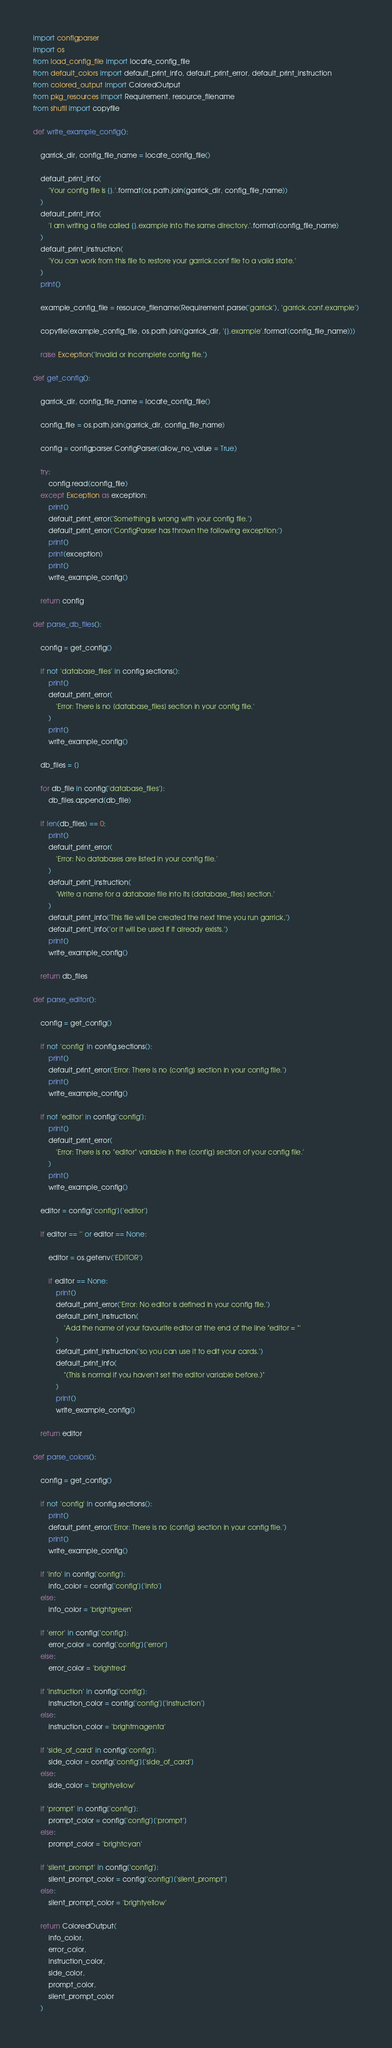<code> <loc_0><loc_0><loc_500><loc_500><_Python_>import configparser
import os
from load_config_file import locate_config_file
from default_colors import default_print_info, default_print_error, default_print_instruction
from colored_output import ColoredOutput
from pkg_resources import Requirement, resource_filename
from shutil import copyfile

def write_example_config():
    
    garrick_dir, config_file_name = locate_config_file()

    default_print_info(
        'Your config file is {}.'.format(os.path.join(garrick_dir, config_file_name))
    )
    default_print_info(
        'I am writing a file called {}.example into the same directory.'.format(config_file_name)
    )
    default_print_instruction(
        'You can work from this file to restore your garrick.conf file to a valid state.'
    )
    print()

    example_config_file = resource_filename(Requirement.parse('garrick'), 'garrick.conf.example')

    copyfile(example_config_file, os.path.join(garrick_dir, '{}.example'.format(config_file_name)))

    raise Exception('Invalid or incomplete config file.')

def get_config():
    
    garrick_dir, config_file_name = locate_config_file()

    config_file = os.path.join(garrick_dir, config_file_name)

    config = configparser.ConfigParser(allow_no_value = True)

    try:
        config.read(config_file)
    except Exception as exception:
        print()
        default_print_error('Something is wrong with your config file.')
        default_print_error('ConfigParser has thrown the following exception:')
        print()
        print(exception)
        print()
        write_example_config()

    return config

def parse_db_files():

    config = get_config()

    if not 'database_files' in config.sections():
        print()
        default_print_error(
            'Error: There is no [database_files] section in your config file.'
        )
        print()
        write_example_config()

    db_files = []

    for db_file in config['database_files']:
        db_files.append(db_file)
        
    if len(db_files) == 0:
        print()
        default_print_error(
            'Error: No databases are listed in your config file.'
        )
        default_print_instruction(
            'Write a name for a database file into its [database_files] section.'
        )
        default_print_info('This file will be created the next time you run garrick,')
        default_print_info('or it will be used if it already exists.')
        print()
        write_example_config()

    return db_files

def parse_editor():

    config = get_config()

    if not 'config' in config.sections():
        print()
        default_print_error('Error: There is no [config] section in your config file.')
        print()
        write_example_config()
        
    if not 'editor' in config['config']:
        print()
        default_print_error(
            'Error: There is no "editor" variable in the [config] section of your config file.'
        )
        print()
        write_example_config()

    editor = config['config']['editor']

    if editor == '' or editor == None:

        editor = os.getenv('EDITOR')
            
        if editor == None:
            print()
            default_print_error('Error: No editor is defined in your config file.')
            default_print_instruction(
                'Add the name of your favourite editor at the end of the line "editor = "'
            )
            default_print_instruction('so you can use it to edit your cards.')
            default_print_info(
                "(This is normal if you haven't set the editor variable before.)"
            )
            print()
            write_example_config()
    
    return editor

def parse_colors():

    config = get_config()

    if not 'config' in config.sections():
        print()
        default_print_error('Error: There is no [config] section in your config file.')
        print()
        write_example_config()

    if 'info' in config['config']:
        info_color = config['config']['info']
    else:
        info_color = 'brightgreen'

    if 'error' in config['config']:
        error_color = config['config']['error']
    else:
        error_color = 'brightred'

    if 'instruction' in config['config']:
        instruction_color = config['config']['instruction']
    else:
        instruction_color = 'brightmagenta'

    if 'side_of_card' in config['config']:
        side_color = config['config']['side_of_card']
    else:
        side_color = 'brightyellow'

    if 'prompt' in config['config']:
        prompt_color = config['config']['prompt']
    else:
        prompt_color = 'brightcyan'

    if 'silent_prompt' in config['config']:
        silent_prompt_color = config['config']['silent_prompt']
    else:
        silent_prompt_color = 'brightyellow'

    return ColoredOutput(
        info_color, 
        error_color,
        instruction_color,
        side_color,
        prompt_color,
        silent_prompt_color
    )
</code> 